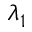<formula> <loc_0><loc_0><loc_500><loc_500>\lambda _ { 1 }</formula> 